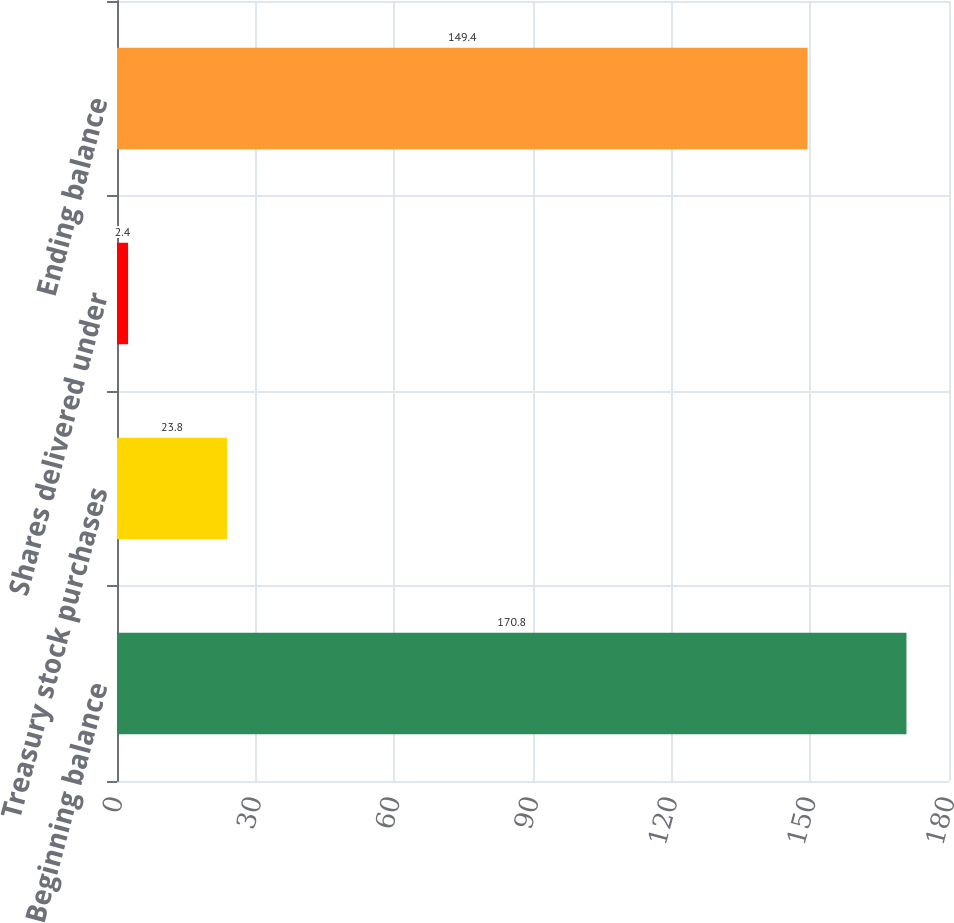Convert chart to OTSL. <chart><loc_0><loc_0><loc_500><loc_500><bar_chart><fcel>Beginning balance<fcel>Treasury stock purchases<fcel>Shares delivered under<fcel>Ending balance<nl><fcel>170.8<fcel>23.8<fcel>2.4<fcel>149.4<nl></chart> 